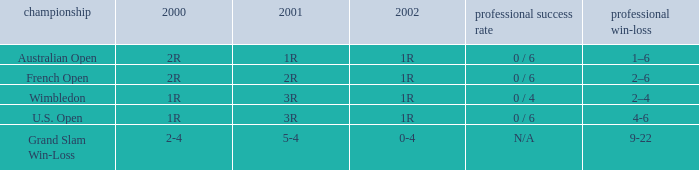In what year 2000 tournment did Angeles Montolio have a career win-loss record of 2-4? Grand Slam Win-Loss. 